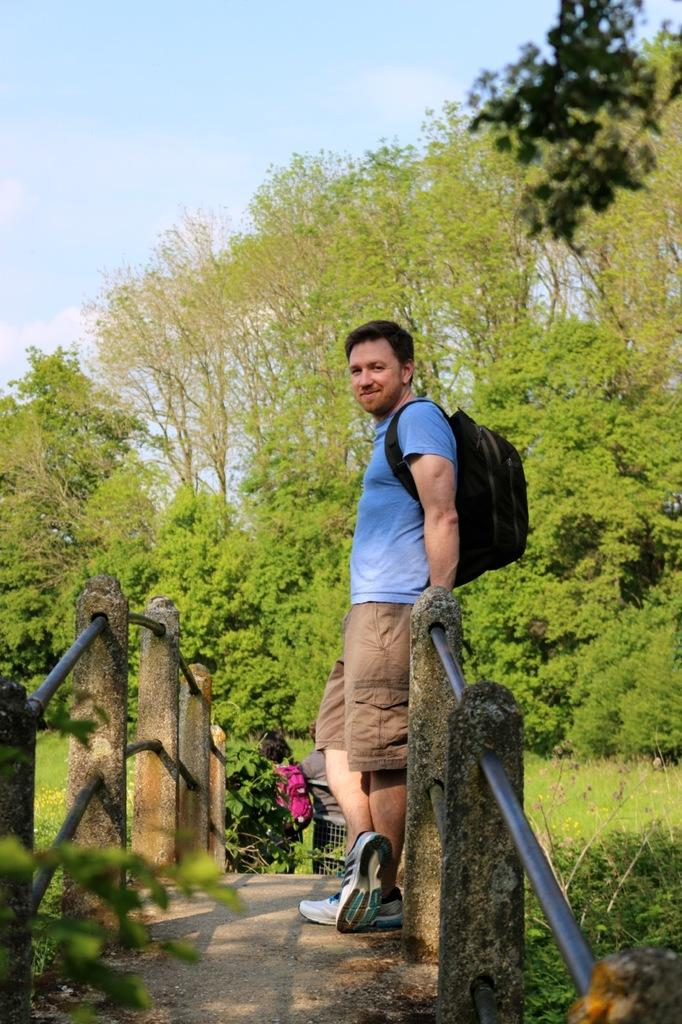What is the main structure in the foreground of the image? There is a bridge in the foreground of the image. Can you describe the person in the image? There is a man standing on the right side of the image. What type of vegetation is visible behind the man? Grass and plants are present behind the man. What can be seen in the background of the image? Trees are visible in the background of the image. What type of eggnog is being served on the bridge in the image? There is no eggnog present in the image; it features a bridge, a man, and vegetation. Can you tell me how much blood is visible on the man's shirt in the image? There is no blood visible on the man's shirt in the image. --- Facts: 1. There is a car in the image. 2. The car is red. 3. The car has four wheels. 4. There is a person sitting in the driver's seat. 5. The car is parked on the side of the road. Absurd Topics: parrot, sandcastle, volcano Conversation: What is the main subject of the image? The main subject of the image is a car. What color is the car? The car is red. How many wheels does the car have? The car has four wheels. Who is inside the car? There is a person sitting in the driver's seat. Where is the car located in the image? The car is parked on the side of the road. Reasoning: Let's think step by step in order to produce the conversation. We start by identifying the main subject of the image, which is the car. Then, we describe the car's color and the number of wheels it has. Next, we mention the person inside the car, noting their position as the driver. Finally, we describe the car's location, which is parked on the side of the road. Absurd Question/Answer: Can you tell me how many parrots are sitting on the roof of the car in the image? There are no parrots present on the roof of the car in the image. What type of sandcastle can be seen in the background of the image? There is no sandcastle present in the background of the image. 